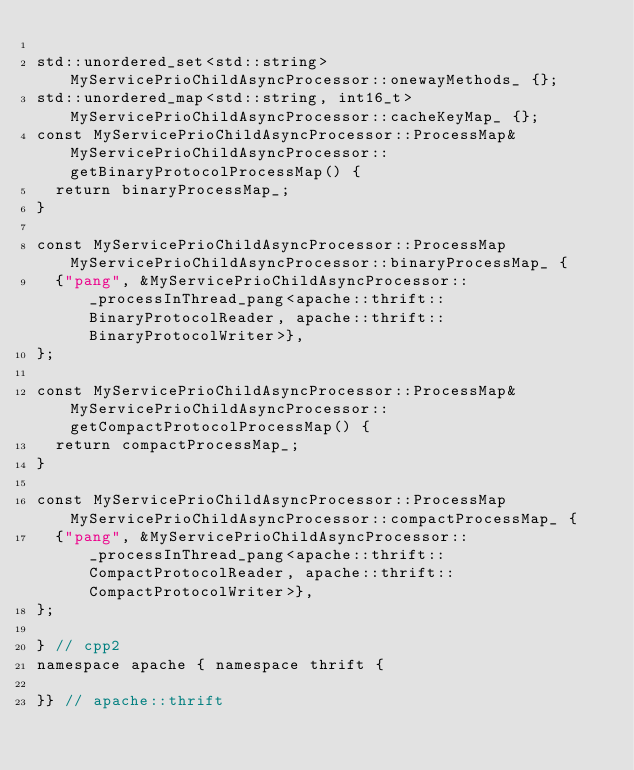Convert code to text. <code><loc_0><loc_0><loc_500><loc_500><_C++_>
std::unordered_set<std::string> MyServicePrioChildAsyncProcessor::onewayMethods_ {};
std::unordered_map<std::string, int16_t> MyServicePrioChildAsyncProcessor::cacheKeyMap_ {};
const MyServicePrioChildAsyncProcessor::ProcessMap& MyServicePrioChildAsyncProcessor::getBinaryProtocolProcessMap() {
  return binaryProcessMap_;
}

const MyServicePrioChildAsyncProcessor::ProcessMap MyServicePrioChildAsyncProcessor::binaryProcessMap_ {
  {"pang", &MyServicePrioChildAsyncProcessor::_processInThread_pang<apache::thrift::BinaryProtocolReader, apache::thrift::BinaryProtocolWriter>},
};

const MyServicePrioChildAsyncProcessor::ProcessMap& MyServicePrioChildAsyncProcessor::getCompactProtocolProcessMap() {
  return compactProcessMap_;
}

const MyServicePrioChildAsyncProcessor::ProcessMap MyServicePrioChildAsyncProcessor::compactProcessMap_ {
  {"pang", &MyServicePrioChildAsyncProcessor::_processInThread_pang<apache::thrift::CompactProtocolReader, apache::thrift::CompactProtocolWriter>},
};

} // cpp2
namespace apache { namespace thrift {

}} // apache::thrift
</code> 